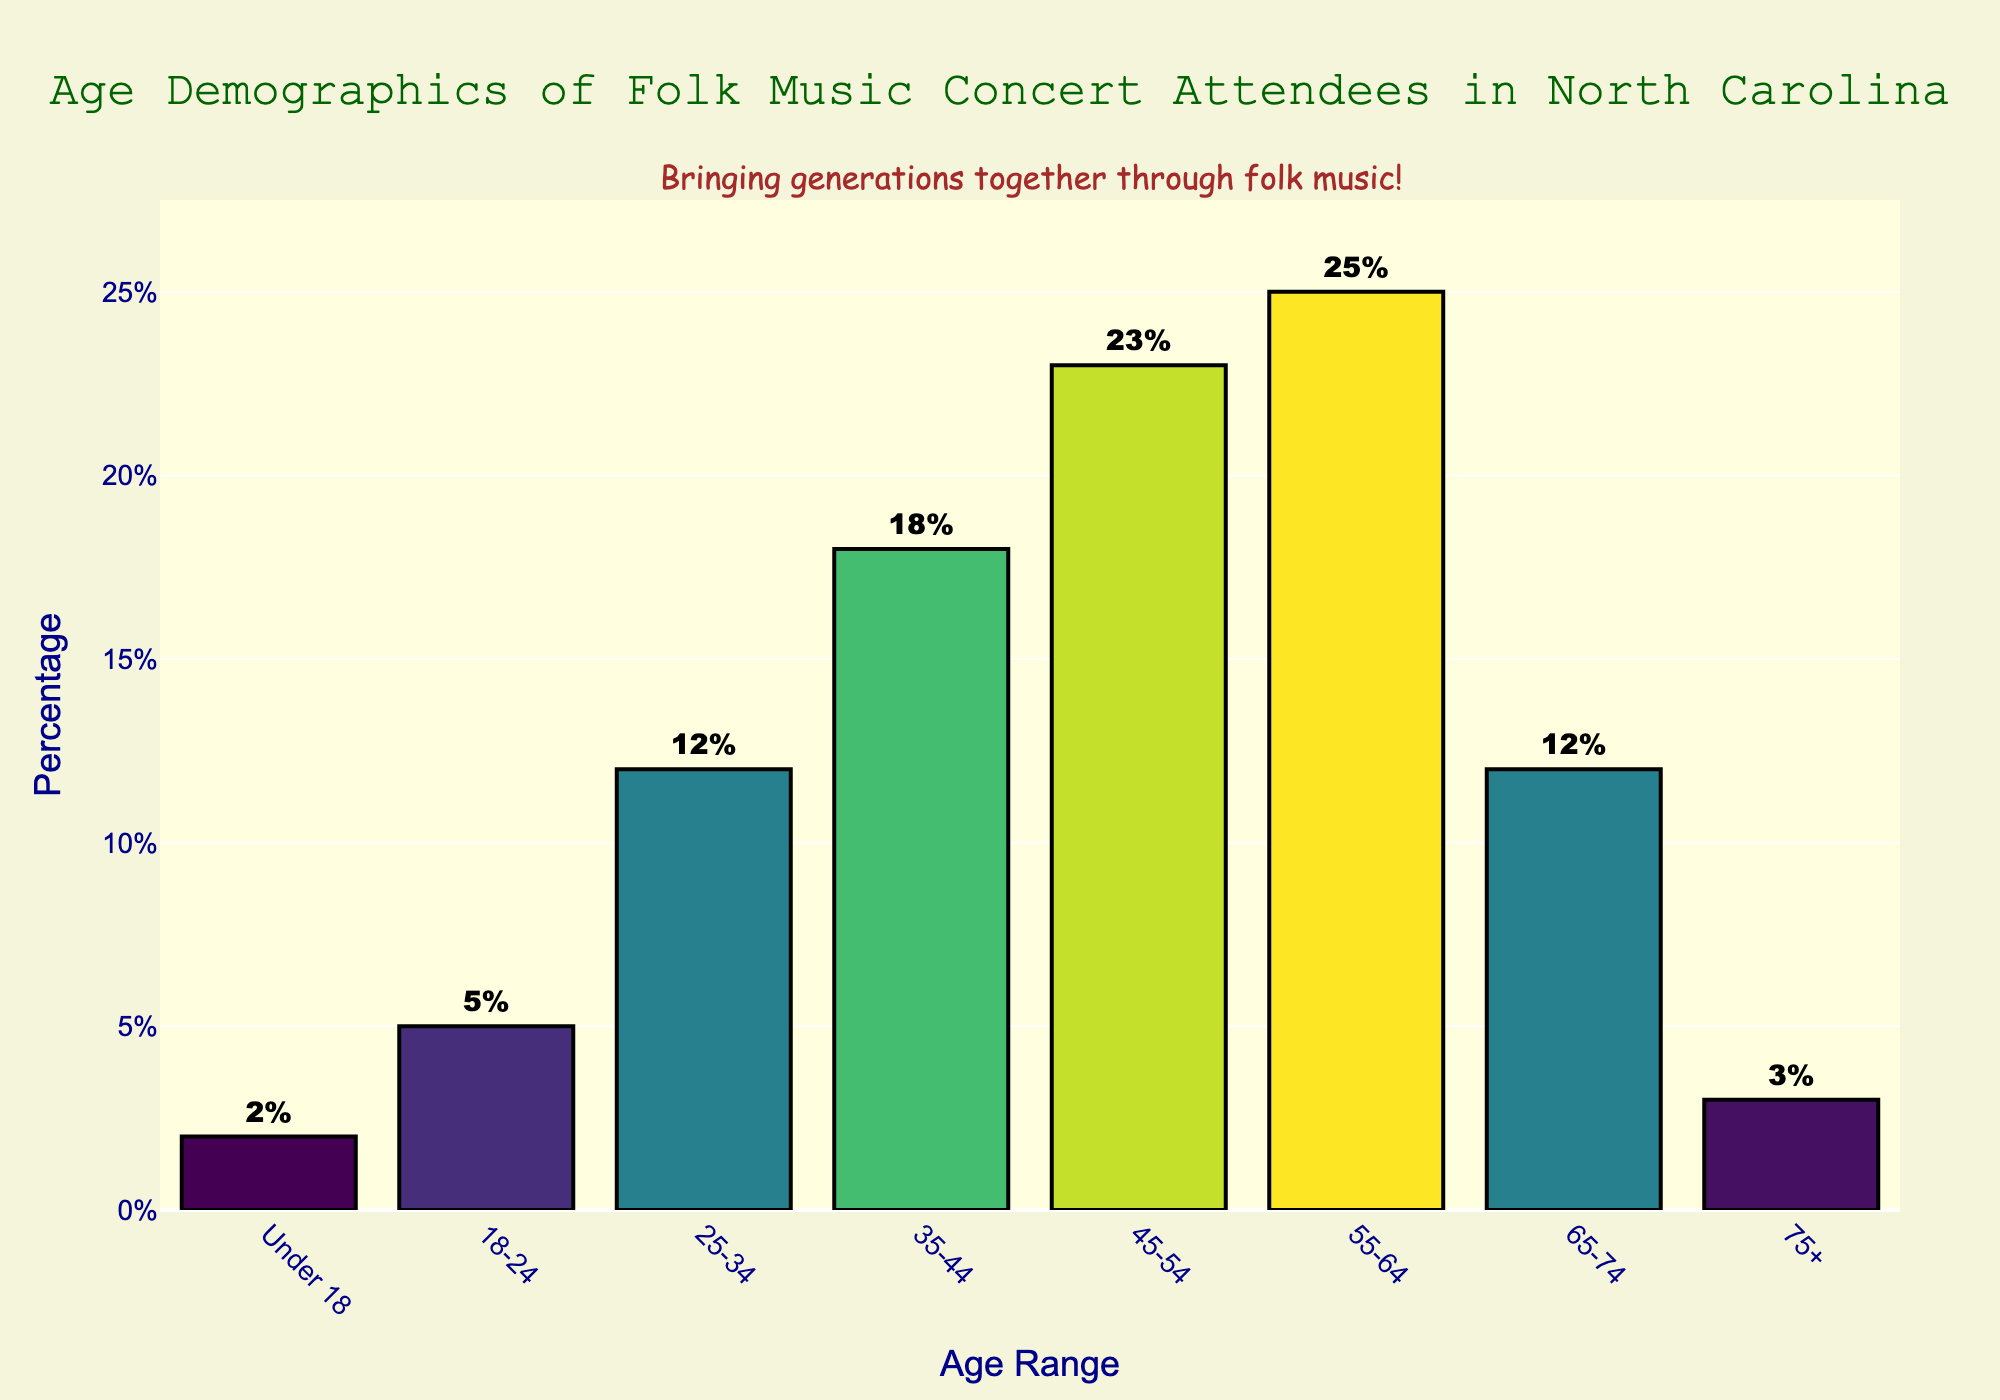What's the age range with the highest percentage of attendees? The age range with the highest bar will indicate the highest percentage. The tallest bar is for the 55-64 age range, showing 25%.
Answer: 55-64 Which age range has fewer attendees, 18-24 or 75+? Compare the percentages for 18-24 (5%) and 75+ (3%). 3% is less than 5%.
Answer: 75+ What is the combined percentage of attendees in the 45-54 and 55-64 age ranges? Add the percentages of the 45-54 age range (23%) and the 55-64 age range (25%). 23% + 25% = 48%.
Answer: 48% How much greater is the percentage of attendees in the 35-44 range compared to those under 18? Subtract the percentage of the Under 18 range (2%) from the 35-44 range (18%). 18% - 2% = 16%.
Answer: 16% What percentage of attendees are aged 65 and older? Add the percentages from the 65-74 (12%) and 75+ (3%) age ranges. 12% + 3% = 15%.
Answer: 15% Which age range has a percentage closer to 12%, 25-34 or 65-74? Both the 25-34 and 65-74 age ranges have a percentage of 12%. Therefore, they are equally close.
Answer: Both Which age range shows a bigger difference in attendees compared to 18-24, the 25-34 range or the 35-44 range? Compare the differences: 18-24 (5%) and 25-34 (12%) is a difference of 7%, while 18-24 (5%) and 35-44 (18%) is a difference of 13%.
Answer: 35-44 Identify two adjacent age ranges where the drop in percentage is most significant. Compare adjacent age ranges: the biggest drop is between 55-64 (25%) and 65-74 (12%), a difference of 13%.
Answer: 55-64 to 65-74 